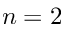Convert formula to latex. <formula><loc_0><loc_0><loc_500><loc_500>n = 2</formula> 